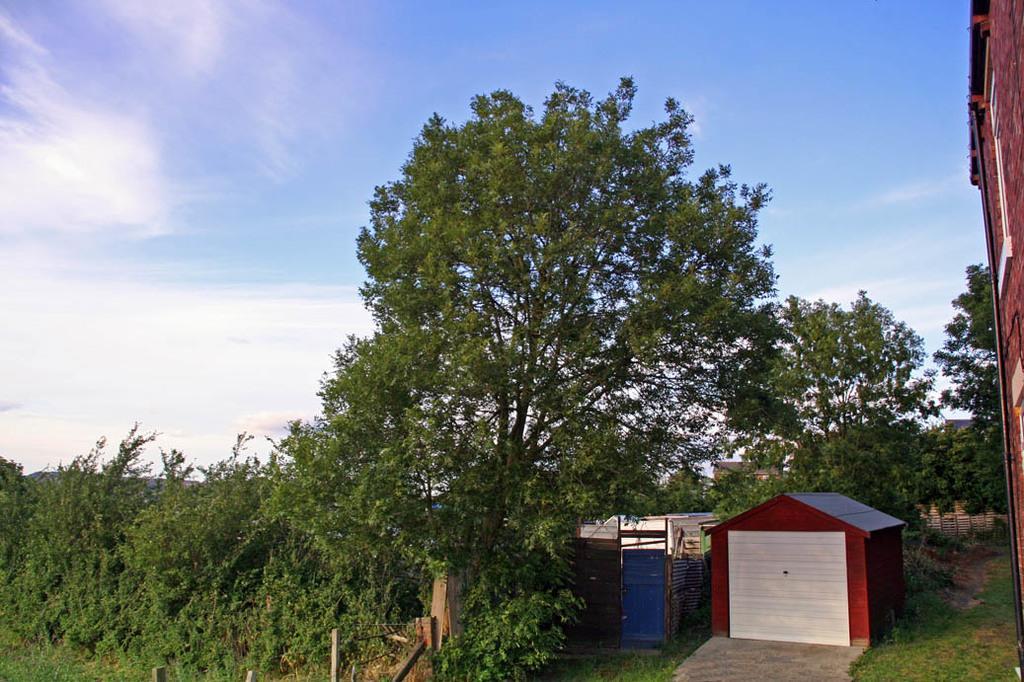Describe this image in one or two sentences. In this picture I can see many trees, plants and grass. In the bottom right I can see the sheds and building. At the top I can see the sky and clouds. At the bottom I can see the fencing and wall partition. 